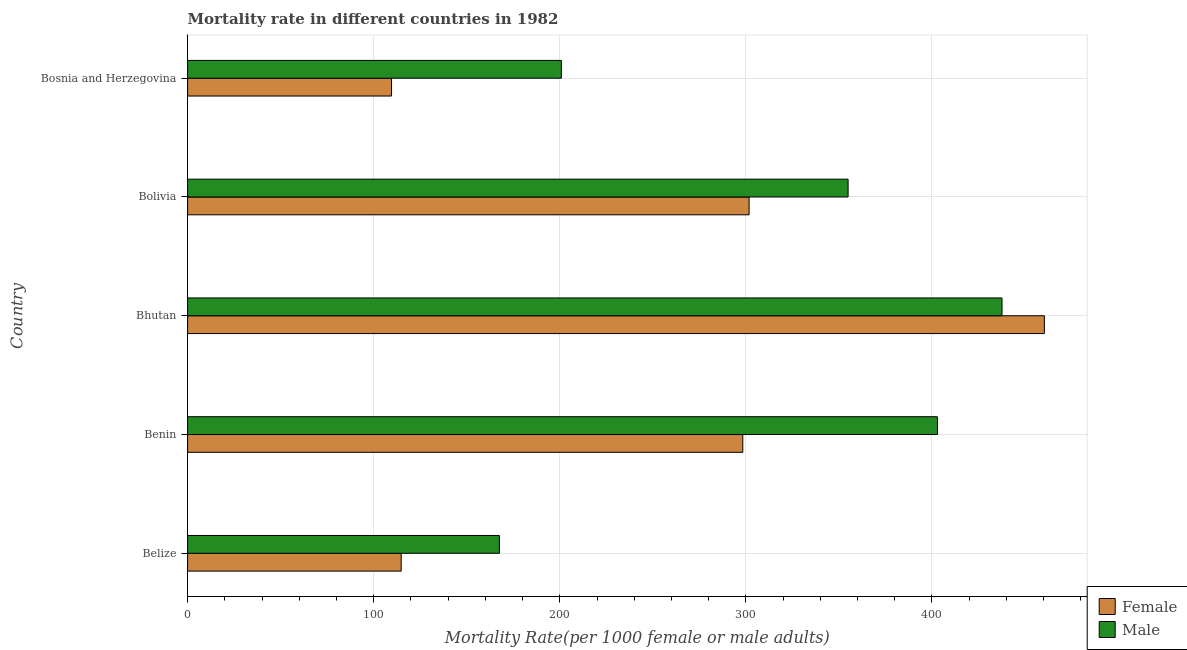How many different coloured bars are there?
Provide a short and direct response. 2. How many groups of bars are there?
Your answer should be very brief. 5. Are the number of bars on each tick of the Y-axis equal?
Your answer should be very brief. Yes. How many bars are there on the 1st tick from the top?
Make the answer very short. 2. What is the label of the 5th group of bars from the top?
Ensure brevity in your answer.  Belize. What is the female mortality rate in Benin?
Your response must be concise. 298.35. Across all countries, what is the maximum female mortality rate?
Provide a short and direct response. 460.4. Across all countries, what is the minimum male mortality rate?
Provide a short and direct response. 167.56. In which country was the male mortality rate maximum?
Your answer should be very brief. Bhutan. In which country was the male mortality rate minimum?
Make the answer very short. Belize. What is the total male mortality rate in the graph?
Provide a short and direct response. 1563.93. What is the difference between the female mortality rate in Bhutan and that in Bosnia and Herzegovina?
Your response must be concise. 350.82. What is the difference between the female mortality rate in Bhutan and the male mortality rate in Bosnia and Herzegovina?
Provide a succinct answer. 259.55. What is the average male mortality rate per country?
Offer a terse response. 312.79. What is the difference between the female mortality rate and male mortality rate in Belize?
Provide a succinct answer. -52.78. In how many countries, is the female mortality rate greater than 300 ?
Your response must be concise. 2. What is the ratio of the male mortality rate in Bhutan to that in Bosnia and Herzegovina?
Give a very brief answer. 2.18. Is the female mortality rate in Bhutan less than that in Bolivia?
Your answer should be very brief. No. Is the difference between the female mortality rate in Benin and Bolivia greater than the difference between the male mortality rate in Benin and Bolivia?
Make the answer very short. No. What is the difference between the highest and the second highest female mortality rate?
Your answer should be compact. 158.67. What is the difference between the highest and the lowest female mortality rate?
Ensure brevity in your answer.  350.82. In how many countries, is the female mortality rate greater than the average female mortality rate taken over all countries?
Offer a very short reply. 3. How many bars are there?
Make the answer very short. 10. Are all the bars in the graph horizontal?
Offer a terse response. Yes. Are the values on the major ticks of X-axis written in scientific E-notation?
Your answer should be compact. No. Does the graph contain any zero values?
Ensure brevity in your answer.  No. How many legend labels are there?
Give a very brief answer. 2. What is the title of the graph?
Your answer should be very brief. Mortality rate in different countries in 1982. What is the label or title of the X-axis?
Make the answer very short. Mortality Rate(per 1000 female or male adults). What is the label or title of the Y-axis?
Make the answer very short. Country. What is the Mortality Rate(per 1000 female or male adults) in Female in Belize?
Provide a short and direct response. 114.78. What is the Mortality Rate(per 1000 female or male adults) of Male in Belize?
Offer a very short reply. 167.56. What is the Mortality Rate(per 1000 female or male adults) of Female in Benin?
Your answer should be very brief. 298.35. What is the Mortality Rate(per 1000 female or male adults) of Male in Benin?
Keep it short and to the point. 402.94. What is the Mortality Rate(per 1000 female or male adults) of Female in Bhutan?
Give a very brief answer. 460.4. What is the Mortality Rate(per 1000 female or male adults) in Male in Bhutan?
Provide a succinct answer. 437.65. What is the Mortality Rate(per 1000 female or male adults) in Female in Bolivia?
Offer a terse response. 301.74. What is the Mortality Rate(per 1000 female or male adults) in Male in Bolivia?
Your answer should be very brief. 354.94. What is the Mortality Rate(per 1000 female or male adults) of Female in Bosnia and Herzegovina?
Give a very brief answer. 109.58. What is the Mortality Rate(per 1000 female or male adults) of Male in Bosnia and Herzegovina?
Provide a succinct answer. 200.85. Across all countries, what is the maximum Mortality Rate(per 1000 female or male adults) in Female?
Offer a very short reply. 460.4. Across all countries, what is the maximum Mortality Rate(per 1000 female or male adults) of Male?
Ensure brevity in your answer.  437.65. Across all countries, what is the minimum Mortality Rate(per 1000 female or male adults) in Female?
Offer a very short reply. 109.58. Across all countries, what is the minimum Mortality Rate(per 1000 female or male adults) of Male?
Your answer should be very brief. 167.56. What is the total Mortality Rate(per 1000 female or male adults) in Female in the graph?
Ensure brevity in your answer.  1284.85. What is the total Mortality Rate(per 1000 female or male adults) of Male in the graph?
Ensure brevity in your answer.  1563.93. What is the difference between the Mortality Rate(per 1000 female or male adults) in Female in Belize and that in Benin?
Your answer should be very brief. -183.57. What is the difference between the Mortality Rate(per 1000 female or male adults) of Male in Belize and that in Benin?
Provide a short and direct response. -235.38. What is the difference between the Mortality Rate(per 1000 female or male adults) of Female in Belize and that in Bhutan?
Provide a succinct answer. -345.62. What is the difference between the Mortality Rate(per 1000 female or male adults) of Male in Belize and that in Bhutan?
Give a very brief answer. -270.1. What is the difference between the Mortality Rate(per 1000 female or male adults) in Female in Belize and that in Bolivia?
Your answer should be compact. -186.96. What is the difference between the Mortality Rate(per 1000 female or male adults) in Male in Belize and that in Bolivia?
Ensure brevity in your answer.  -187.38. What is the difference between the Mortality Rate(per 1000 female or male adults) of Female in Belize and that in Bosnia and Herzegovina?
Keep it short and to the point. 5.2. What is the difference between the Mortality Rate(per 1000 female or male adults) in Male in Belize and that in Bosnia and Herzegovina?
Offer a very short reply. -33.29. What is the difference between the Mortality Rate(per 1000 female or male adults) in Female in Benin and that in Bhutan?
Provide a short and direct response. -162.05. What is the difference between the Mortality Rate(per 1000 female or male adults) in Male in Benin and that in Bhutan?
Make the answer very short. -34.71. What is the difference between the Mortality Rate(per 1000 female or male adults) of Female in Benin and that in Bolivia?
Your answer should be compact. -3.38. What is the difference between the Mortality Rate(per 1000 female or male adults) in Male in Benin and that in Bolivia?
Ensure brevity in your answer.  48. What is the difference between the Mortality Rate(per 1000 female or male adults) of Female in Benin and that in Bosnia and Herzegovina?
Ensure brevity in your answer.  188.77. What is the difference between the Mortality Rate(per 1000 female or male adults) in Male in Benin and that in Bosnia and Herzegovina?
Ensure brevity in your answer.  202.09. What is the difference between the Mortality Rate(per 1000 female or male adults) of Female in Bhutan and that in Bolivia?
Offer a terse response. 158.67. What is the difference between the Mortality Rate(per 1000 female or male adults) in Male in Bhutan and that in Bolivia?
Keep it short and to the point. 82.72. What is the difference between the Mortality Rate(per 1000 female or male adults) in Female in Bhutan and that in Bosnia and Herzegovina?
Make the answer very short. 350.82. What is the difference between the Mortality Rate(per 1000 female or male adults) of Male in Bhutan and that in Bosnia and Herzegovina?
Offer a terse response. 236.8. What is the difference between the Mortality Rate(per 1000 female or male adults) of Female in Bolivia and that in Bosnia and Herzegovina?
Offer a terse response. 192.16. What is the difference between the Mortality Rate(per 1000 female or male adults) of Male in Bolivia and that in Bosnia and Herzegovina?
Offer a terse response. 154.09. What is the difference between the Mortality Rate(per 1000 female or male adults) of Female in Belize and the Mortality Rate(per 1000 female or male adults) of Male in Benin?
Offer a terse response. -288.16. What is the difference between the Mortality Rate(per 1000 female or male adults) of Female in Belize and the Mortality Rate(per 1000 female or male adults) of Male in Bhutan?
Make the answer very short. -322.87. What is the difference between the Mortality Rate(per 1000 female or male adults) of Female in Belize and the Mortality Rate(per 1000 female or male adults) of Male in Bolivia?
Offer a terse response. -240.16. What is the difference between the Mortality Rate(per 1000 female or male adults) of Female in Belize and the Mortality Rate(per 1000 female or male adults) of Male in Bosnia and Herzegovina?
Provide a succinct answer. -86.07. What is the difference between the Mortality Rate(per 1000 female or male adults) of Female in Benin and the Mortality Rate(per 1000 female or male adults) of Male in Bhutan?
Give a very brief answer. -139.3. What is the difference between the Mortality Rate(per 1000 female or male adults) in Female in Benin and the Mortality Rate(per 1000 female or male adults) in Male in Bolivia?
Give a very brief answer. -56.58. What is the difference between the Mortality Rate(per 1000 female or male adults) of Female in Benin and the Mortality Rate(per 1000 female or male adults) of Male in Bosnia and Herzegovina?
Keep it short and to the point. 97.5. What is the difference between the Mortality Rate(per 1000 female or male adults) of Female in Bhutan and the Mortality Rate(per 1000 female or male adults) of Male in Bolivia?
Offer a very short reply. 105.47. What is the difference between the Mortality Rate(per 1000 female or male adults) in Female in Bhutan and the Mortality Rate(per 1000 female or male adults) in Male in Bosnia and Herzegovina?
Offer a terse response. 259.55. What is the difference between the Mortality Rate(per 1000 female or male adults) of Female in Bolivia and the Mortality Rate(per 1000 female or male adults) of Male in Bosnia and Herzegovina?
Your answer should be very brief. 100.89. What is the average Mortality Rate(per 1000 female or male adults) of Female per country?
Keep it short and to the point. 256.97. What is the average Mortality Rate(per 1000 female or male adults) of Male per country?
Keep it short and to the point. 312.79. What is the difference between the Mortality Rate(per 1000 female or male adults) of Female and Mortality Rate(per 1000 female or male adults) of Male in Belize?
Ensure brevity in your answer.  -52.78. What is the difference between the Mortality Rate(per 1000 female or male adults) of Female and Mortality Rate(per 1000 female or male adults) of Male in Benin?
Offer a terse response. -104.59. What is the difference between the Mortality Rate(per 1000 female or male adults) of Female and Mortality Rate(per 1000 female or male adults) of Male in Bhutan?
Keep it short and to the point. 22.75. What is the difference between the Mortality Rate(per 1000 female or male adults) of Female and Mortality Rate(per 1000 female or male adults) of Male in Bolivia?
Provide a succinct answer. -53.2. What is the difference between the Mortality Rate(per 1000 female or male adults) in Female and Mortality Rate(per 1000 female or male adults) in Male in Bosnia and Herzegovina?
Offer a terse response. -91.27. What is the ratio of the Mortality Rate(per 1000 female or male adults) in Female in Belize to that in Benin?
Make the answer very short. 0.38. What is the ratio of the Mortality Rate(per 1000 female or male adults) of Male in Belize to that in Benin?
Make the answer very short. 0.42. What is the ratio of the Mortality Rate(per 1000 female or male adults) in Female in Belize to that in Bhutan?
Offer a terse response. 0.25. What is the ratio of the Mortality Rate(per 1000 female or male adults) in Male in Belize to that in Bhutan?
Provide a short and direct response. 0.38. What is the ratio of the Mortality Rate(per 1000 female or male adults) in Female in Belize to that in Bolivia?
Your response must be concise. 0.38. What is the ratio of the Mortality Rate(per 1000 female or male adults) of Male in Belize to that in Bolivia?
Give a very brief answer. 0.47. What is the ratio of the Mortality Rate(per 1000 female or male adults) in Female in Belize to that in Bosnia and Herzegovina?
Your response must be concise. 1.05. What is the ratio of the Mortality Rate(per 1000 female or male adults) of Male in Belize to that in Bosnia and Herzegovina?
Ensure brevity in your answer.  0.83. What is the ratio of the Mortality Rate(per 1000 female or male adults) in Female in Benin to that in Bhutan?
Your answer should be compact. 0.65. What is the ratio of the Mortality Rate(per 1000 female or male adults) of Male in Benin to that in Bhutan?
Offer a very short reply. 0.92. What is the ratio of the Mortality Rate(per 1000 female or male adults) in Female in Benin to that in Bolivia?
Offer a terse response. 0.99. What is the ratio of the Mortality Rate(per 1000 female or male adults) of Male in Benin to that in Bolivia?
Ensure brevity in your answer.  1.14. What is the ratio of the Mortality Rate(per 1000 female or male adults) of Female in Benin to that in Bosnia and Herzegovina?
Make the answer very short. 2.72. What is the ratio of the Mortality Rate(per 1000 female or male adults) of Male in Benin to that in Bosnia and Herzegovina?
Make the answer very short. 2.01. What is the ratio of the Mortality Rate(per 1000 female or male adults) in Female in Bhutan to that in Bolivia?
Keep it short and to the point. 1.53. What is the ratio of the Mortality Rate(per 1000 female or male adults) of Male in Bhutan to that in Bolivia?
Provide a succinct answer. 1.23. What is the ratio of the Mortality Rate(per 1000 female or male adults) in Female in Bhutan to that in Bosnia and Herzegovina?
Your answer should be very brief. 4.2. What is the ratio of the Mortality Rate(per 1000 female or male adults) of Male in Bhutan to that in Bosnia and Herzegovina?
Your response must be concise. 2.18. What is the ratio of the Mortality Rate(per 1000 female or male adults) of Female in Bolivia to that in Bosnia and Herzegovina?
Offer a terse response. 2.75. What is the ratio of the Mortality Rate(per 1000 female or male adults) of Male in Bolivia to that in Bosnia and Herzegovina?
Make the answer very short. 1.77. What is the difference between the highest and the second highest Mortality Rate(per 1000 female or male adults) of Female?
Your answer should be compact. 158.67. What is the difference between the highest and the second highest Mortality Rate(per 1000 female or male adults) in Male?
Keep it short and to the point. 34.71. What is the difference between the highest and the lowest Mortality Rate(per 1000 female or male adults) in Female?
Give a very brief answer. 350.82. What is the difference between the highest and the lowest Mortality Rate(per 1000 female or male adults) in Male?
Provide a short and direct response. 270.1. 